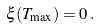Convert formula to latex. <formula><loc_0><loc_0><loc_500><loc_500>\xi ( T _ { \max } ) = 0 \, .</formula> 